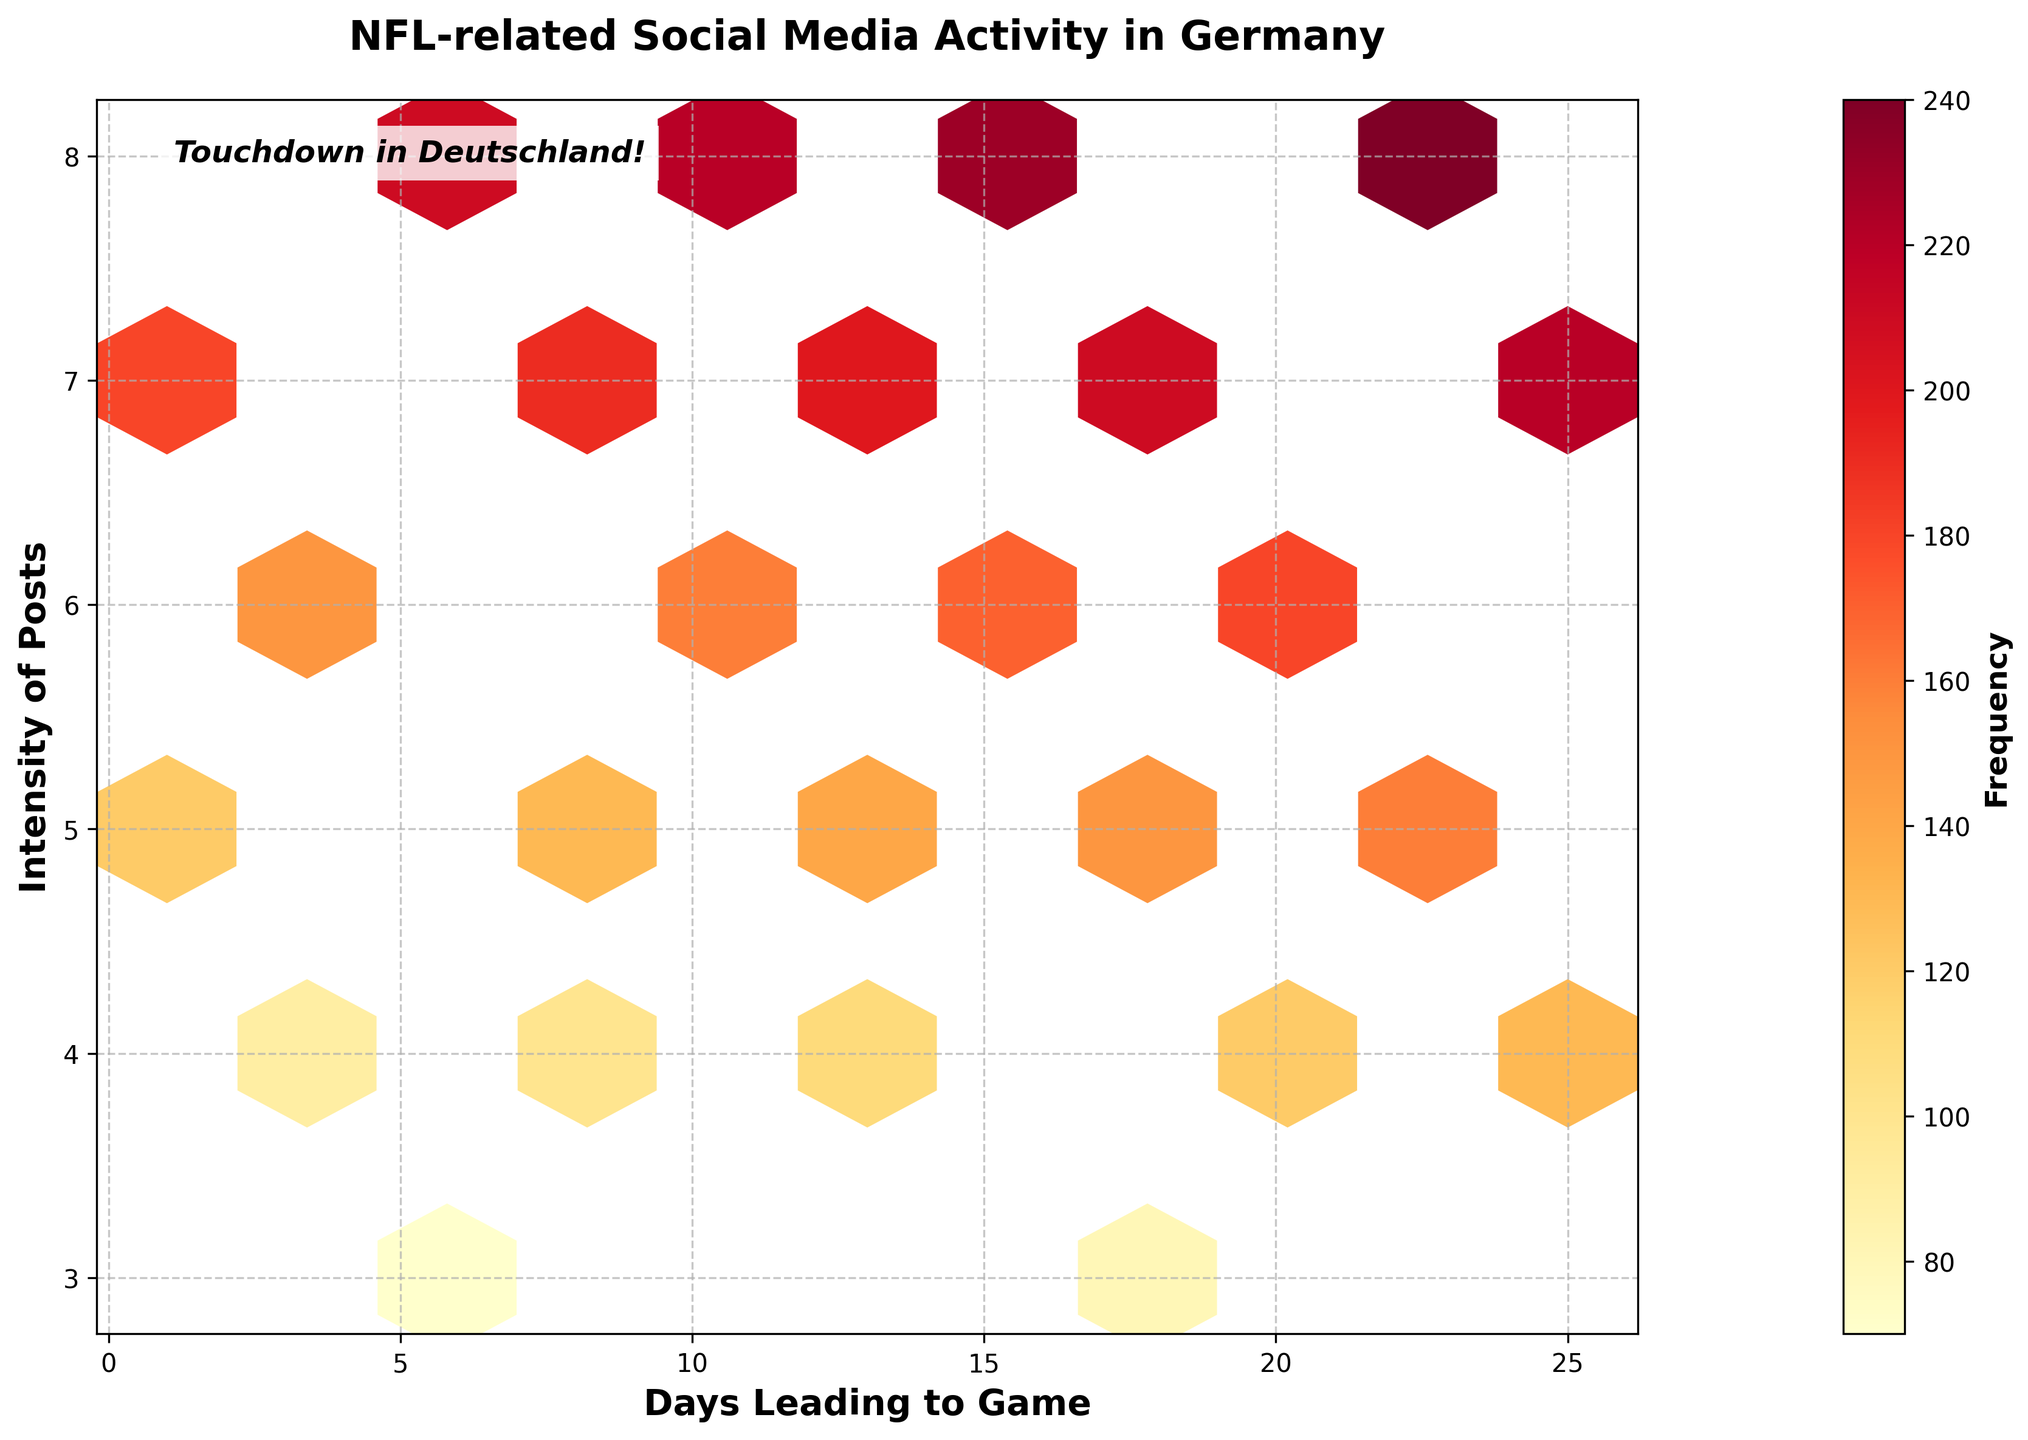How many hexagons are there in the plot? The hexbin plot has a gridsize setting that divides the space into hexagons. Count the visible hexagons in the plot.
Answer: 10 What is the color of the hexagons representing the highest frequency of posts? The color intensity in the plot represents the frequency. Identify the color corresponding to the highest frequency on the plot’s color scale (legend).
Answer: Dark red What does the y-axis label represent? The y-axis label indicates what the vertical axis in the plot is measuring. Look at the y-axis label title on the left-hand side of the plot.
Answer: Intensity of Posts On which day does the highest frequency of NFL-related social media posts occur? Find the hexagon with the darkest color (indicating the highest frequency) and note the corresponding day on the x-axis below it.
Answer: Day 22 Which day has the lowest intensity of NFL-related social media posts? Identify the hexagons with the lowest position on the y-axis (smallest y-value), which represents the intensity of posts, and note the corresponding x-value (day).
Answer: Day 6 How does social media activity change as the game day approaches? Observe the general trend of hexagon colors (representing frequency) and positions (representing intensity) as x-values (days) increase on the plot.
Answer: Activity increases What is the frequency range in the hexbin plot? Check the colorbar legend on the side, indicating the scale of frequency values from minimum to maximum.
Answer: 70 to 240 Which day has more social media post intensity: Day 10 or Day 15? Compare the hexagons corresponding to Day 10 and Day 15 along the y-axis to see which one is higher.
Answer: Day 15 What is the average intensity of posts for the first 10 days? Identify the y-values for the first 10 days and calculate their average: (5+7+4+6+8+3+5+7+4+6)/10.
Answer: 5.5 Does the plot indicate any significant outliers in frequency? Look across the hexbin plot for any hexagons that are significantly different in color (frequency) compared to others.
Answer: Yes, on Day 22 